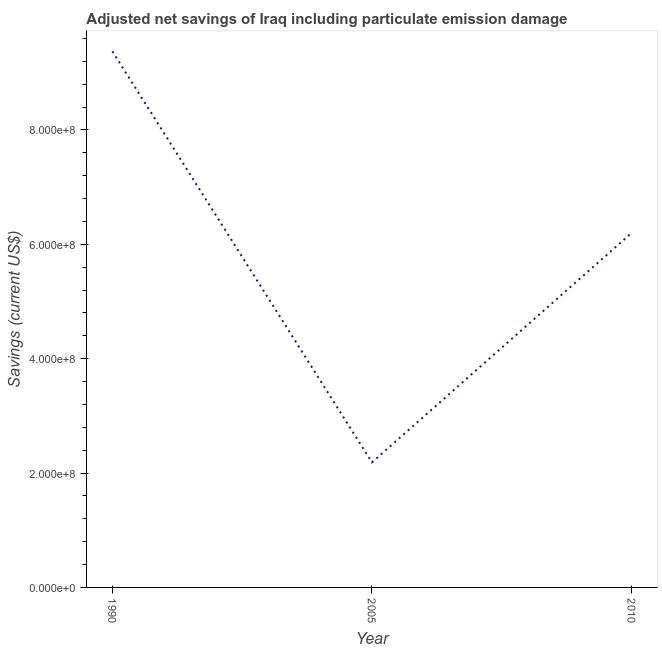What is the adjusted net savings in 2010?
Keep it short and to the point. 6.20e+08. Across all years, what is the maximum adjusted net savings?
Give a very brief answer. 9.38e+08. Across all years, what is the minimum adjusted net savings?
Ensure brevity in your answer.  2.19e+08. In which year was the adjusted net savings maximum?
Provide a succinct answer. 1990. In which year was the adjusted net savings minimum?
Give a very brief answer. 2005. What is the sum of the adjusted net savings?
Your answer should be compact. 1.78e+09. What is the difference between the adjusted net savings in 1990 and 2010?
Ensure brevity in your answer.  3.18e+08. What is the average adjusted net savings per year?
Offer a terse response. 5.92e+08. What is the median adjusted net savings?
Make the answer very short. 6.20e+08. What is the ratio of the adjusted net savings in 1990 to that in 2010?
Offer a terse response. 1.51. Is the difference between the adjusted net savings in 2005 and 2010 greater than the difference between any two years?
Offer a very short reply. No. What is the difference between the highest and the second highest adjusted net savings?
Your response must be concise. 3.18e+08. What is the difference between the highest and the lowest adjusted net savings?
Your answer should be compact. 7.19e+08. In how many years, is the adjusted net savings greater than the average adjusted net savings taken over all years?
Provide a succinct answer. 2. Does the adjusted net savings monotonically increase over the years?
Ensure brevity in your answer.  No. How many lines are there?
Provide a short and direct response. 1. How many years are there in the graph?
Your answer should be very brief. 3. What is the difference between two consecutive major ticks on the Y-axis?
Keep it short and to the point. 2.00e+08. Are the values on the major ticks of Y-axis written in scientific E-notation?
Offer a very short reply. Yes. What is the title of the graph?
Provide a short and direct response. Adjusted net savings of Iraq including particulate emission damage. What is the label or title of the Y-axis?
Your answer should be compact. Savings (current US$). What is the Savings (current US$) of 1990?
Keep it short and to the point. 9.38e+08. What is the Savings (current US$) of 2005?
Offer a terse response. 2.19e+08. What is the Savings (current US$) of 2010?
Your answer should be compact. 6.20e+08. What is the difference between the Savings (current US$) in 1990 and 2005?
Provide a succinct answer. 7.19e+08. What is the difference between the Savings (current US$) in 1990 and 2010?
Ensure brevity in your answer.  3.18e+08. What is the difference between the Savings (current US$) in 2005 and 2010?
Your response must be concise. -4.01e+08. What is the ratio of the Savings (current US$) in 1990 to that in 2005?
Your answer should be very brief. 4.29. What is the ratio of the Savings (current US$) in 1990 to that in 2010?
Make the answer very short. 1.51. What is the ratio of the Savings (current US$) in 2005 to that in 2010?
Provide a short and direct response. 0.35. 